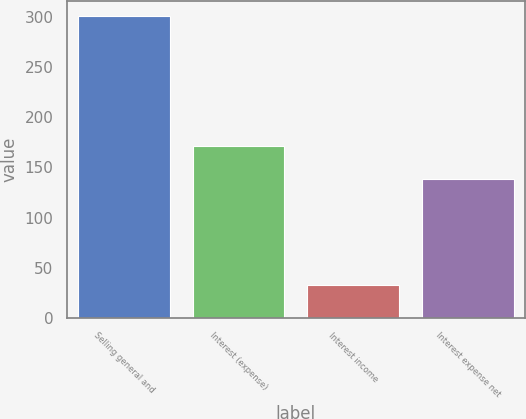Convert chart. <chart><loc_0><loc_0><loc_500><loc_500><bar_chart><fcel>Selling general and<fcel>Interest (expense)<fcel>Interest income<fcel>Interest expense net<nl><fcel>301.3<fcel>171.3<fcel>33.2<fcel>138.1<nl></chart> 